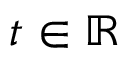<formula> <loc_0><loc_0><loc_500><loc_500>t \in \mathbb { R }</formula> 